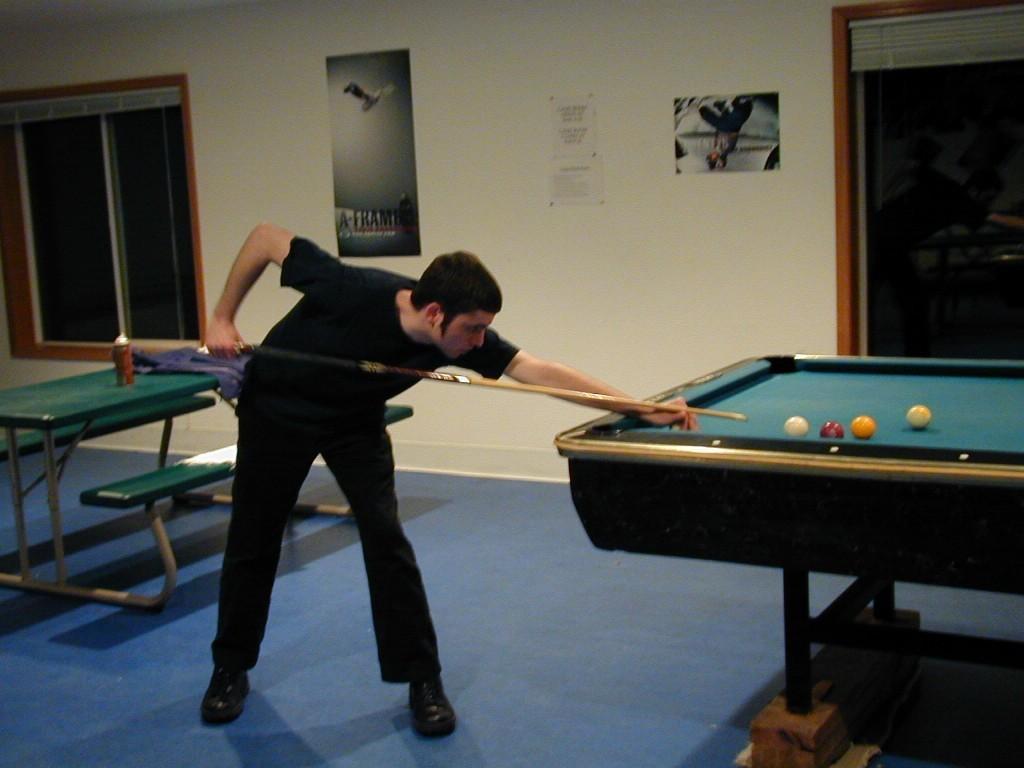In one or two sentences, can you explain what this image depicts? Man in black t-shirt and black pant is playing Snooker Pool game. Behind him, we see a green table and green bench. Beside that, we see windows and a wall on which posters are sticked and beside that, we see a glass door. 